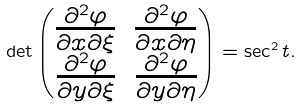<formula> <loc_0><loc_0><loc_500><loc_500>\det \begin{pmatrix} \frac { \partial ^ { 2 } \varphi } { \partial x \partial \xi } & \frac { \partial ^ { 2 } \varphi } { \partial x \partial \eta } \\ \frac { \partial ^ { 2 } \varphi } { \partial y \partial \xi } & \frac { \partial ^ { 2 } \varphi } { \partial y \partial \eta } \end{pmatrix} = \sec ^ { 2 } t .</formula> 